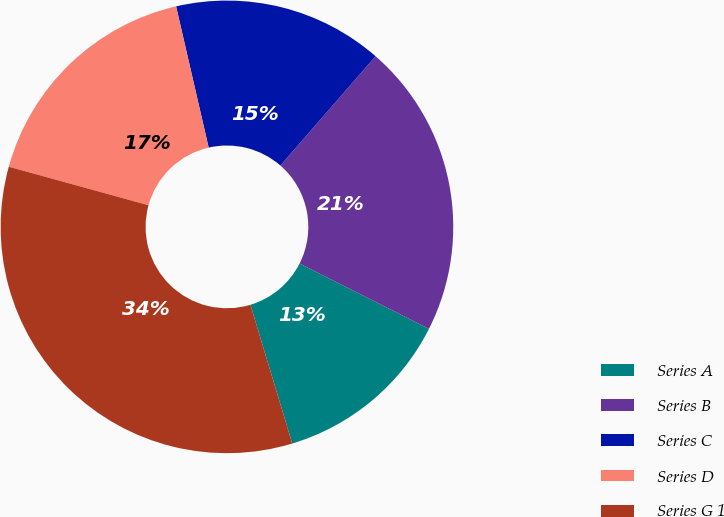<chart> <loc_0><loc_0><loc_500><loc_500><pie_chart><fcel>Series A<fcel>Series B<fcel>Series C<fcel>Series D<fcel>Series G 1<nl><fcel>12.9%<fcel>21.04%<fcel>15.01%<fcel>17.11%<fcel>33.94%<nl></chart> 